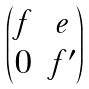Convert formula to latex. <formula><loc_0><loc_0><loc_500><loc_500>\begin{pmatrix} f & e \\ 0 & f ^ { \prime } \end{pmatrix}</formula> 